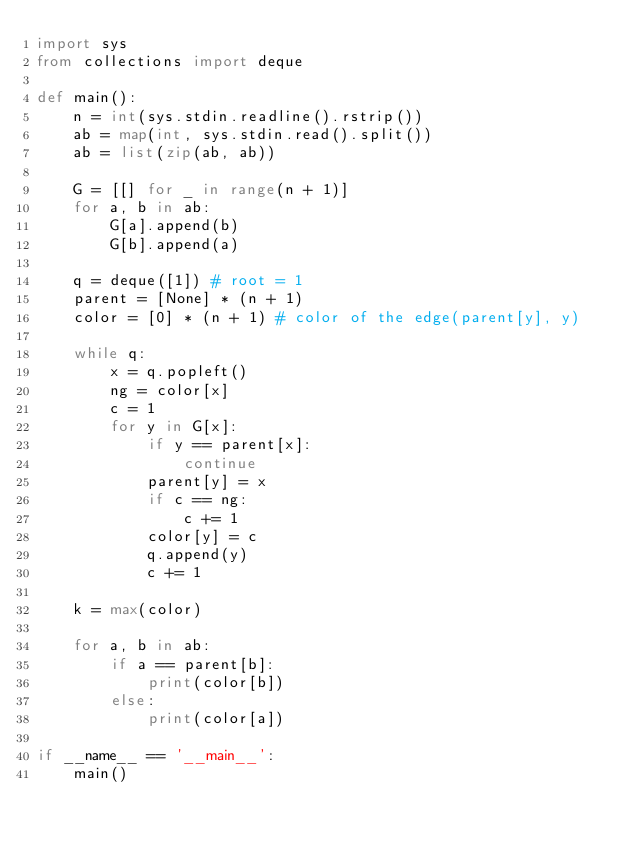<code> <loc_0><loc_0><loc_500><loc_500><_Python_>import sys
from collections import deque

def main():
    n = int(sys.stdin.readline().rstrip())
    ab = map(int, sys.stdin.read().split())
    ab = list(zip(ab, ab))

    G = [[] for _ in range(n + 1)]
    for a, b in ab:
        G[a].append(b)
        G[b].append(a)
    
    q = deque([1]) # root = 1
    parent = [None] * (n + 1)
    color = [0] * (n + 1) # color of the edge(parent[y], y)

    while q:
        x = q.popleft()
        ng = color[x]
        c = 1
        for y in G[x]:
            if y == parent[x]:
                continue
            parent[y] = x
            if c == ng:
                c += 1
            color[y] = c
            q.append(y)
            c += 1
            
    k = max(color)

    for a, b in ab:
        if a == parent[b]:
            print(color[b])
        else:
            print(color[a])

if __name__ == '__main__':
    main()</code> 